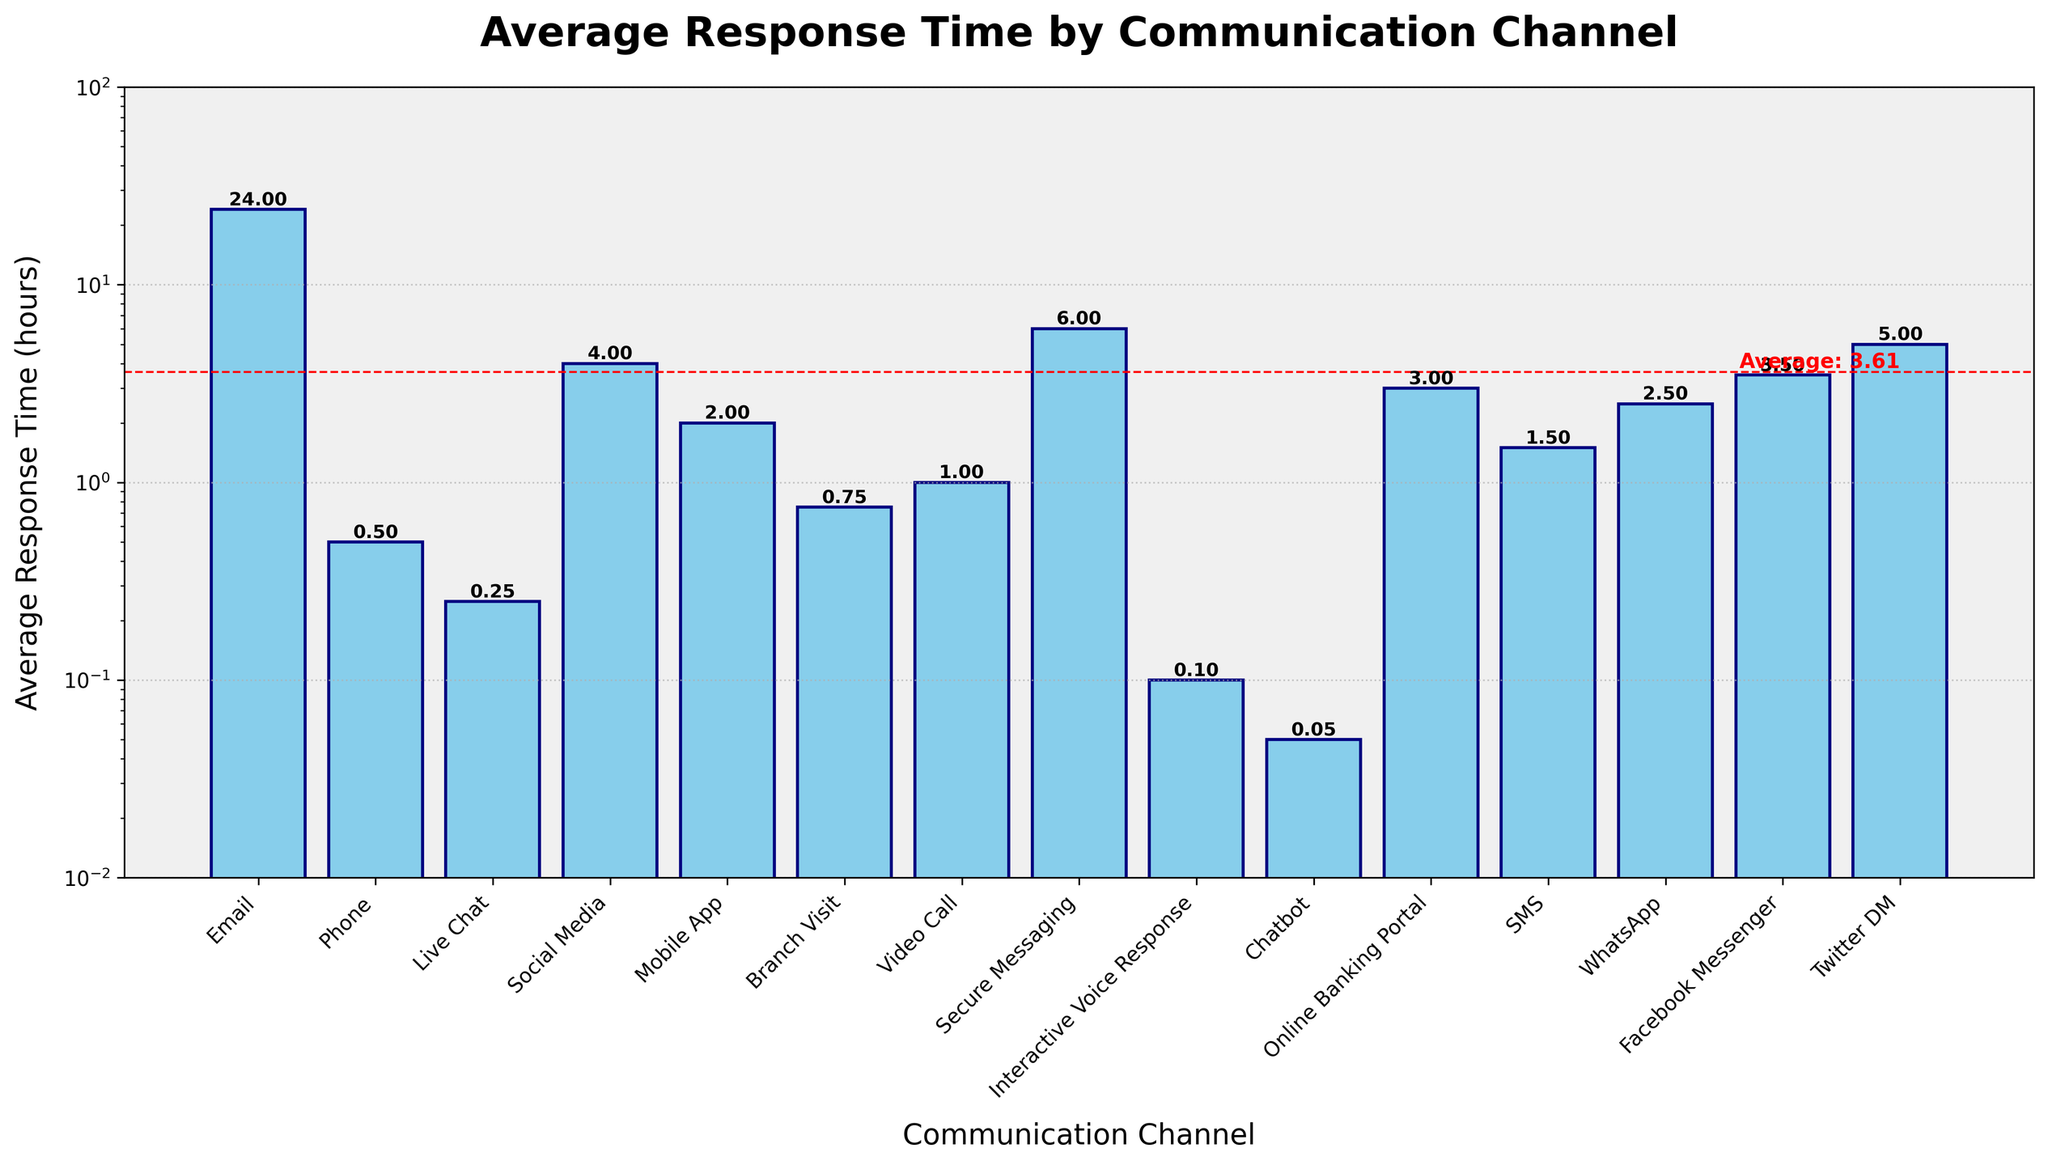What's the shortest average response time among all communication channels? To find the shortest average response time, look at the heights of the bars. The bar for "Chatbot" is the shortest, indicating the shortest average response time of 0.05 hours.
Answer: 0.05 Which communication channel has the longest average response time? To identify the longest average response time, find the tallest bar. The "Secure Messaging" bar is the tallest, indicating the longest average response time of 6 hours.
Answer: 6 How many communication channels have an average response time less than 1 hour? Count the bars that represent an average response time less than 1 hour. These include "Interactive Voice Response" (0.1), "Chatbot" (0.05), "Phone" (0.5), "Live Chat" (0.25), and "Branch Visit" (0.75). There are 5 such bars.
Answer: 5 What is the average response time for all communication channels? The average response time is shown as a red dashed horizontal line on the figure with the label "Average: X.XX". Following this line, you find it indicates approximately 3 hours.
Answer: 3 Which communication channels have an average response time exactly double the "Phone" response time? The "Phone" response time is 0.5 hours. Doubling this gives 1 hour. The channel with a 1-hour response time is "SMS."
Answer: SMS Which communication channel has a faster response time, "Live Chat" or "Social Media"? Compare the heights of the bars for "Live Chat" and "Social Media." The "Live Chat" bar is shorter at 0.25 hours, while "Social Media" is 4 hours. Therefore, "Live Chat" has a faster response time.
Answer: Live Chat What is the combined average response time for "Online Banking Portal" and "Facebook Messenger"? The average response time for "Online Banking Portal" is 3 hours, and for "Facebook Messenger," it is 3.5 hours. Adding these together gives 6.5 hours.
Answer: 6.5 Which is higher, the sum of the response times for "Mobile App" and "WhatsApp", or the response time for "Twitter DM"? The response time for "Mobile App" is 2 hours and for "WhatsApp" is 2.5 hours. Their sum is 4.5 hours. The response time for "Twitter DM" is 5 hours. Therefore, the response time for "Twitter DM" is higher.
Answer: Twitter DM How does the response time for "Branch Visit" compare to the overall average response time? The bar for "Branch Visit" indicates a response time of 0.75 hours. The overall average response time, shown by the red dashed line, is approximately 3 hours. Therefore, the response time for "Branch Visit" is lower than the overall average response time.
Answer: Lower Which two communication channels have response times closest to the average response time of 3 hours? The average response time is around 3 hours. The channels closest to this are "Online Banking Portal" (3 hours) and "Facebook Messenger" (3.5 hours).
Answer: Online Banking Portal, Facebook Messenger 